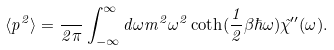Convert formula to latex. <formula><loc_0><loc_0><loc_500><loc_500>\langle p ^ { 2 } \rangle = \frac { } { 2 \pi } \int _ { - \infty } ^ { \infty } d \omega m ^ { 2 } \omega ^ { 2 } \coth ( \frac { 1 } { 2 } \beta \hbar { \omega } ) \tilde { \chi } ^ { \prime \prime } ( \omega ) .</formula> 